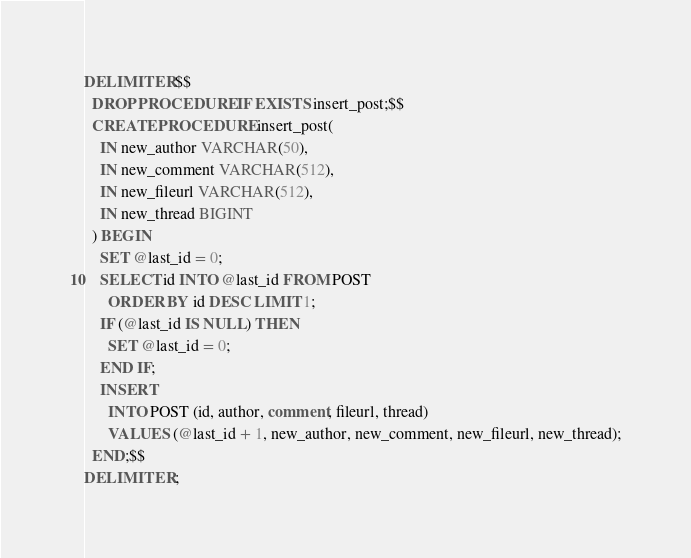<code> <loc_0><loc_0><loc_500><loc_500><_SQL_>DELIMITER $$
  DROP PROCEDURE IF EXISTS insert_post;$$
  CREATE PROCEDURE insert_post(
    IN new_author VARCHAR(50),
    IN new_comment VARCHAR(512),
    IN new_fileurl VARCHAR(512),
    IN new_thread BIGINT
  ) BEGIN
    SET @last_id = 0;
    SELECT id INTO @last_id FROM POST
      ORDER BY id DESC LIMIT 1;
    IF (@last_id IS NULL) THEN
      SET @last_id = 0;
    END IF;
    INSERT
      INTO POST (id, author, comment, fileurl, thread)
      VALUES (@last_id + 1, new_author, new_comment, new_fileurl, new_thread);
  END;$$
DELIMITER ;
</code> 